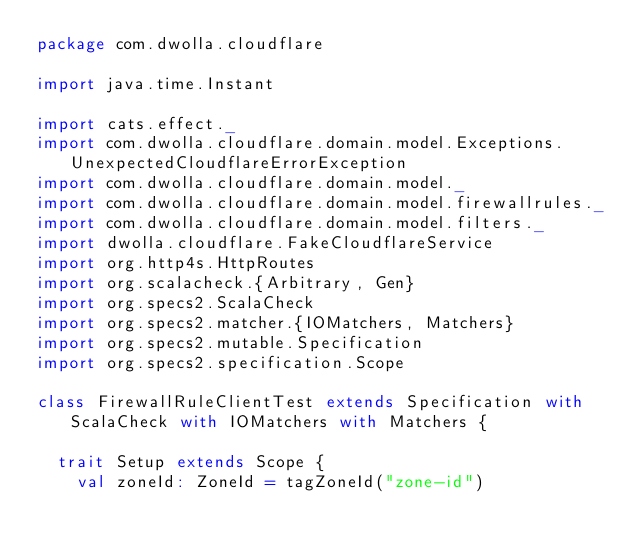Convert code to text. <code><loc_0><loc_0><loc_500><loc_500><_Scala_>package com.dwolla.cloudflare

import java.time.Instant

import cats.effect._
import com.dwolla.cloudflare.domain.model.Exceptions.UnexpectedCloudflareErrorException
import com.dwolla.cloudflare.domain.model._
import com.dwolla.cloudflare.domain.model.firewallrules._
import com.dwolla.cloudflare.domain.model.filters._
import dwolla.cloudflare.FakeCloudflareService
import org.http4s.HttpRoutes
import org.scalacheck.{Arbitrary, Gen}
import org.specs2.ScalaCheck
import org.specs2.matcher.{IOMatchers, Matchers}
import org.specs2.mutable.Specification
import org.specs2.specification.Scope

class FirewallRuleClientTest extends Specification with ScalaCheck with IOMatchers with Matchers {

  trait Setup extends Scope {
    val zoneId: ZoneId = tagZoneId("zone-id")</code> 